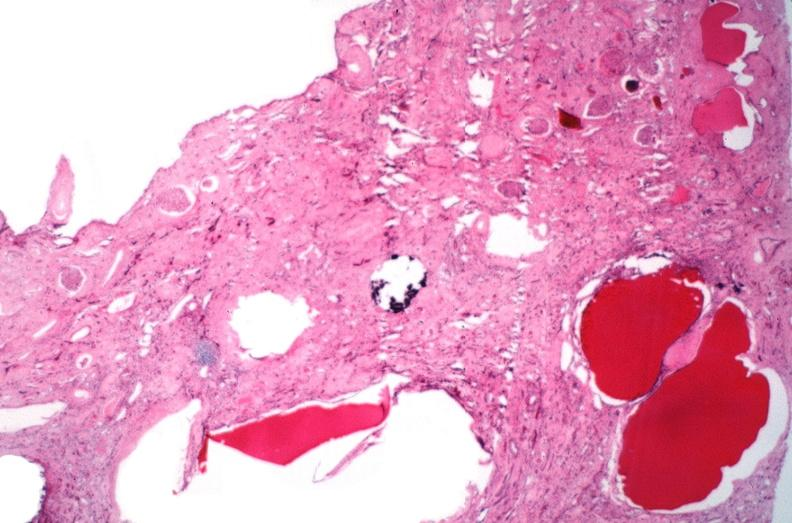does palmar crease normal show kidney, adult polycystic kidney?
Answer the question using a single word or phrase. No 